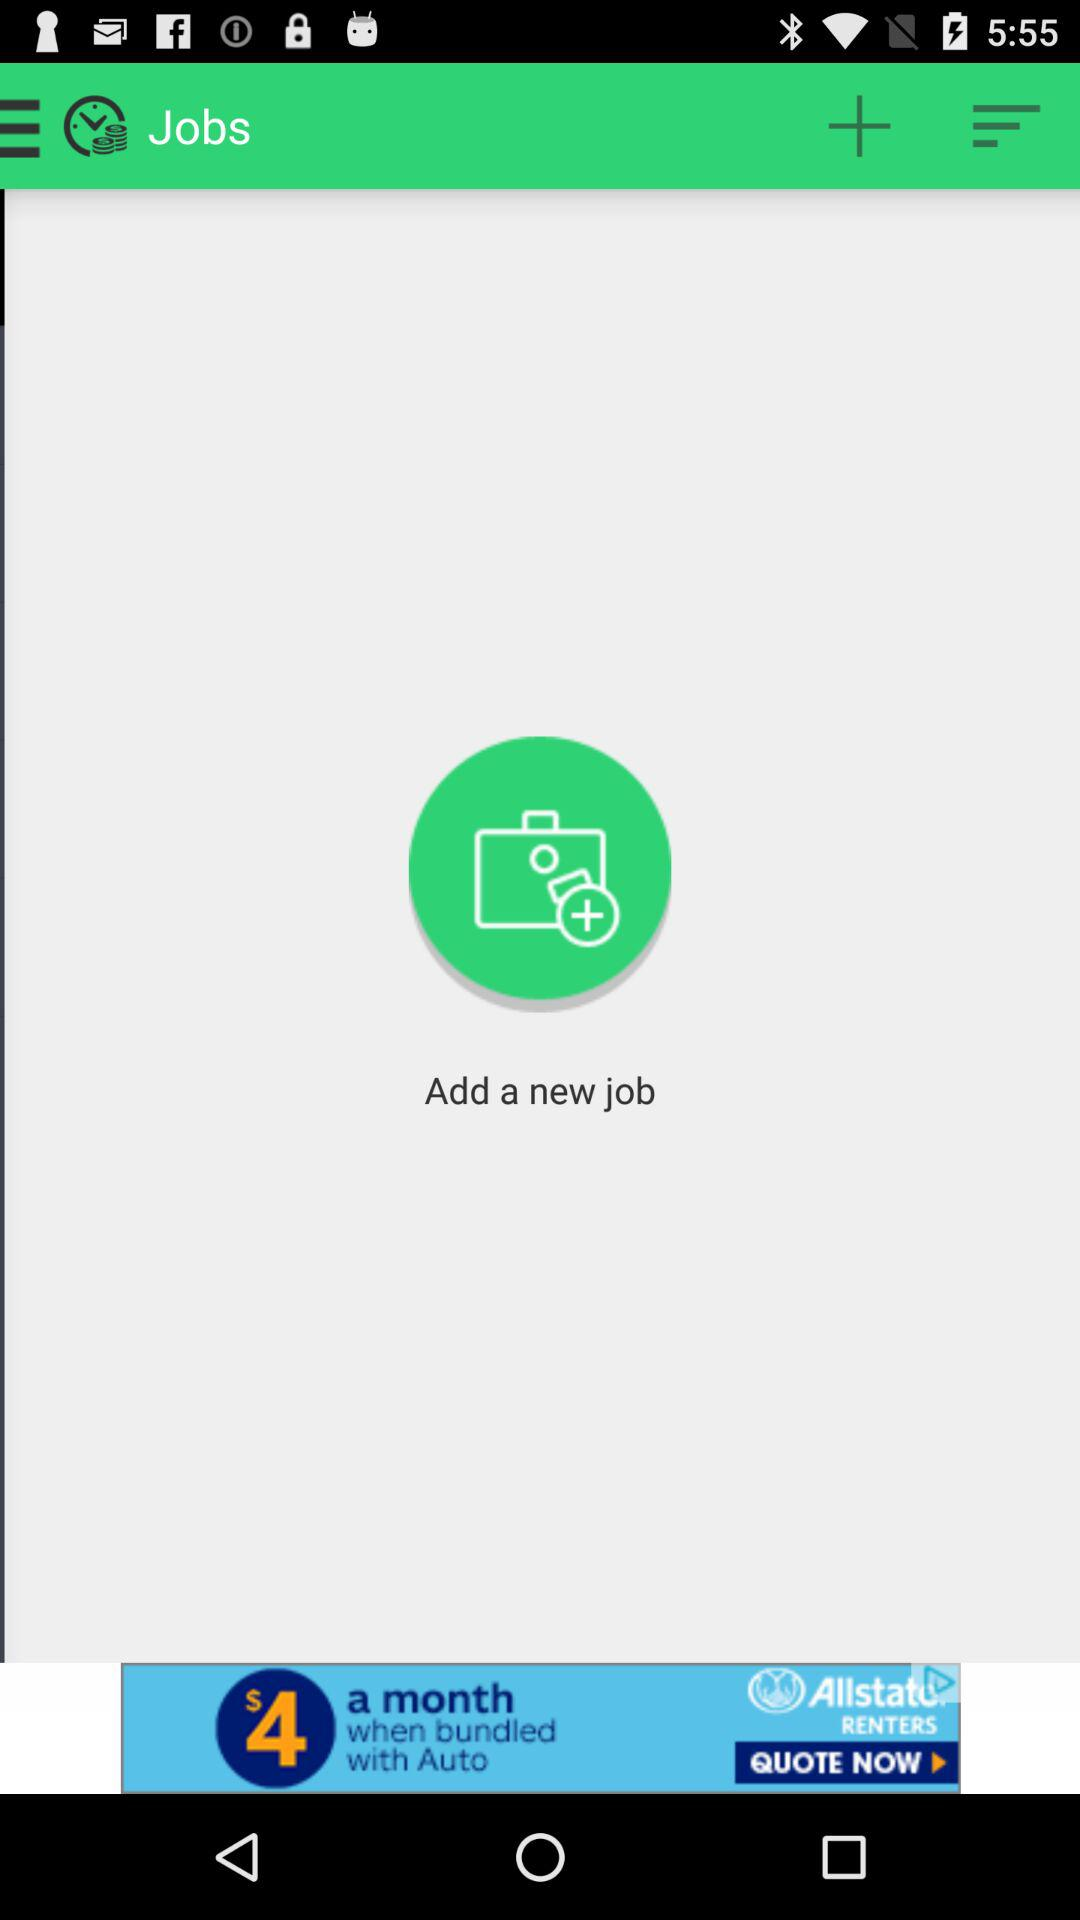What is the application name?
When the provided information is insufficient, respond with <no answer>. <no answer> 